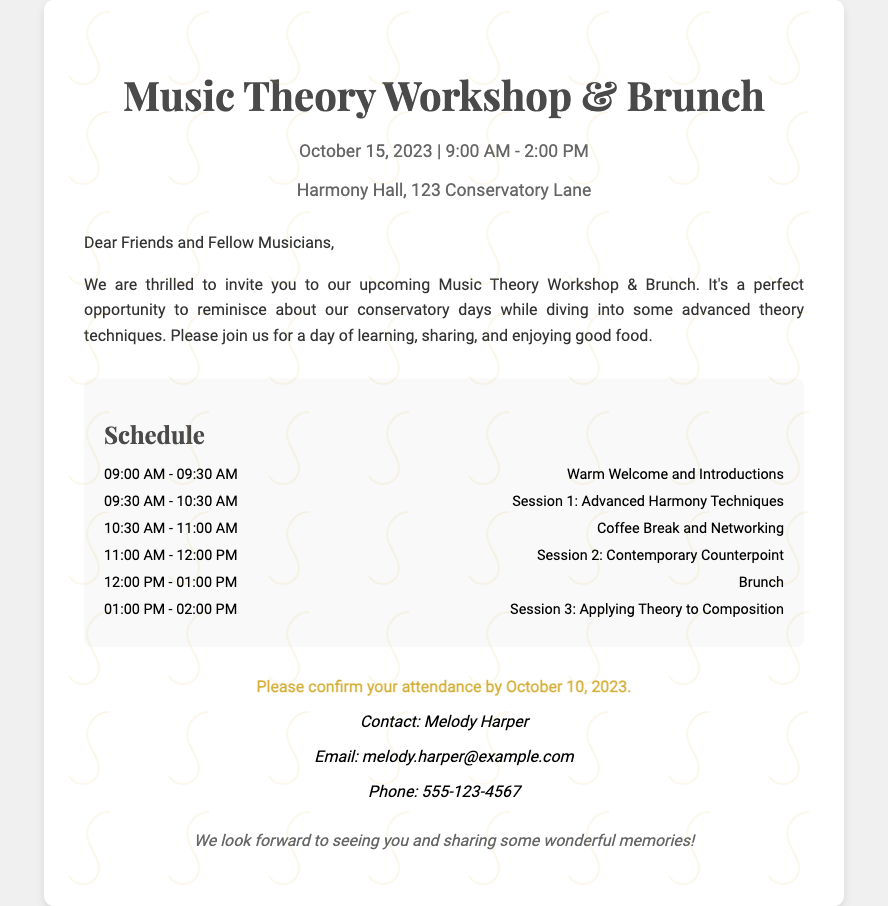What is the date of the event? The date of the event is listed in the event details section of the document.
Answer: October 15, 2023 What time does the brunch start? The brunch start time is specified in the schedule section of the document.
Answer: 12:00 PM Who is the contact person for the event? The contact person's name is mentioned in the RSVP section of the document.
Answer: Melody Harper What session follows the coffee break? This session is detailed in the schedule, following the coffee break.
Answer: Session 2: Contemporary Counterpoint How long is the networking coffee break? The duration of the coffee break is indicated in the schedule.
Answer: 30 minutes What is the location of the event? The location is provided in the event details section of the document.
Answer: Harmony Hall, 123 Conservatory Lane What is the last session of the workshop? The last session is mentioned at the end of the schedule section.
Answer: Session 3: Applying Theory to Composition By when should attendees confirm their attendance? The deadline for confirmation is clearly stated in the RSVP section of the document.
Answer: October 10, 2023 What is the color of the treble clef in the background? The color is mentioned implicitly in the styling of the background image.
Answer: Gold 